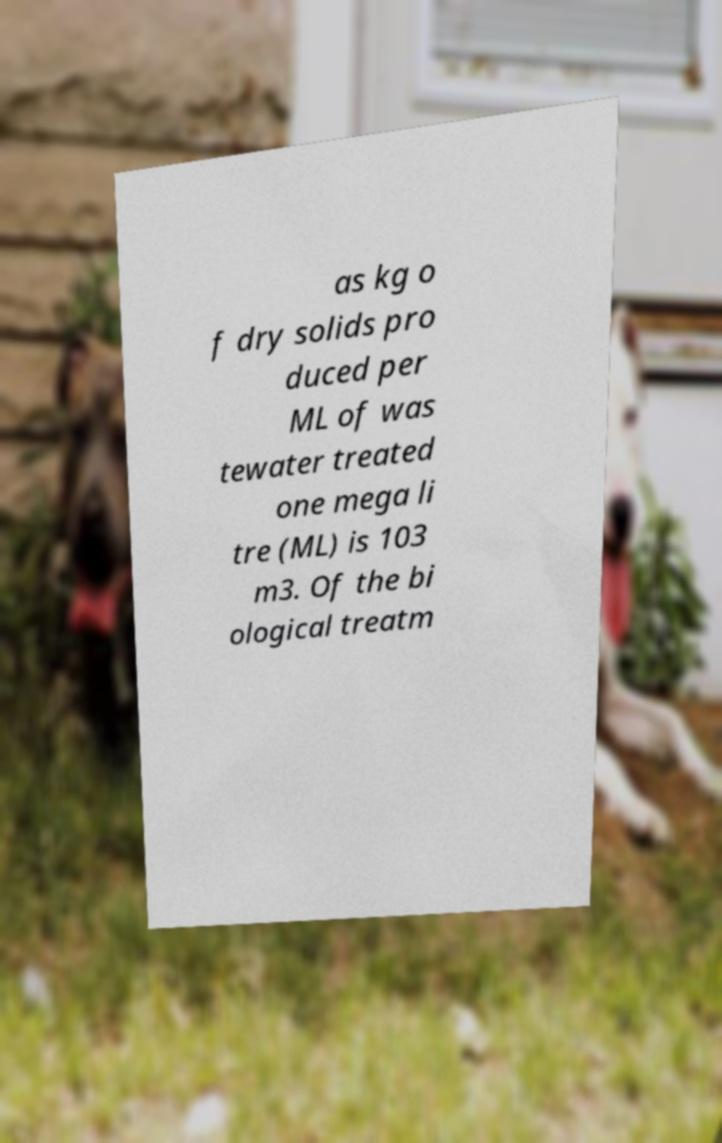I need the written content from this picture converted into text. Can you do that? as kg o f dry solids pro duced per ML of was tewater treated one mega li tre (ML) is 103 m3. Of the bi ological treatm 